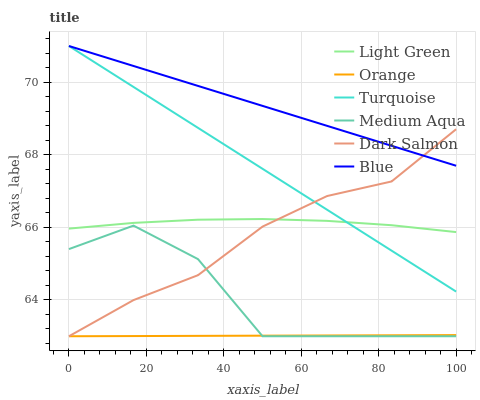Does Orange have the minimum area under the curve?
Answer yes or no. Yes. Does Blue have the maximum area under the curve?
Answer yes or no. Yes. Does Turquoise have the minimum area under the curve?
Answer yes or no. No. Does Turquoise have the maximum area under the curve?
Answer yes or no. No. Is Orange the smoothest?
Answer yes or no. Yes. Is Medium Aqua the roughest?
Answer yes or no. Yes. Is Turquoise the smoothest?
Answer yes or no. No. Is Turquoise the roughest?
Answer yes or no. No. Does Dark Salmon have the lowest value?
Answer yes or no. Yes. Does Turquoise have the lowest value?
Answer yes or no. No. Does Turquoise have the highest value?
Answer yes or no. Yes. Does Dark Salmon have the highest value?
Answer yes or no. No. Is Orange less than Turquoise?
Answer yes or no. Yes. Is Blue greater than Orange?
Answer yes or no. Yes. Does Medium Aqua intersect Orange?
Answer yes or no. Yes. Is Medium Aqua less than Orange?
Answer yes or no. No. Is Medium Aqua greater than Orange?
Answer yes or no. No. Does Orange intersect Turquoise?
Answer yes or no. No. 